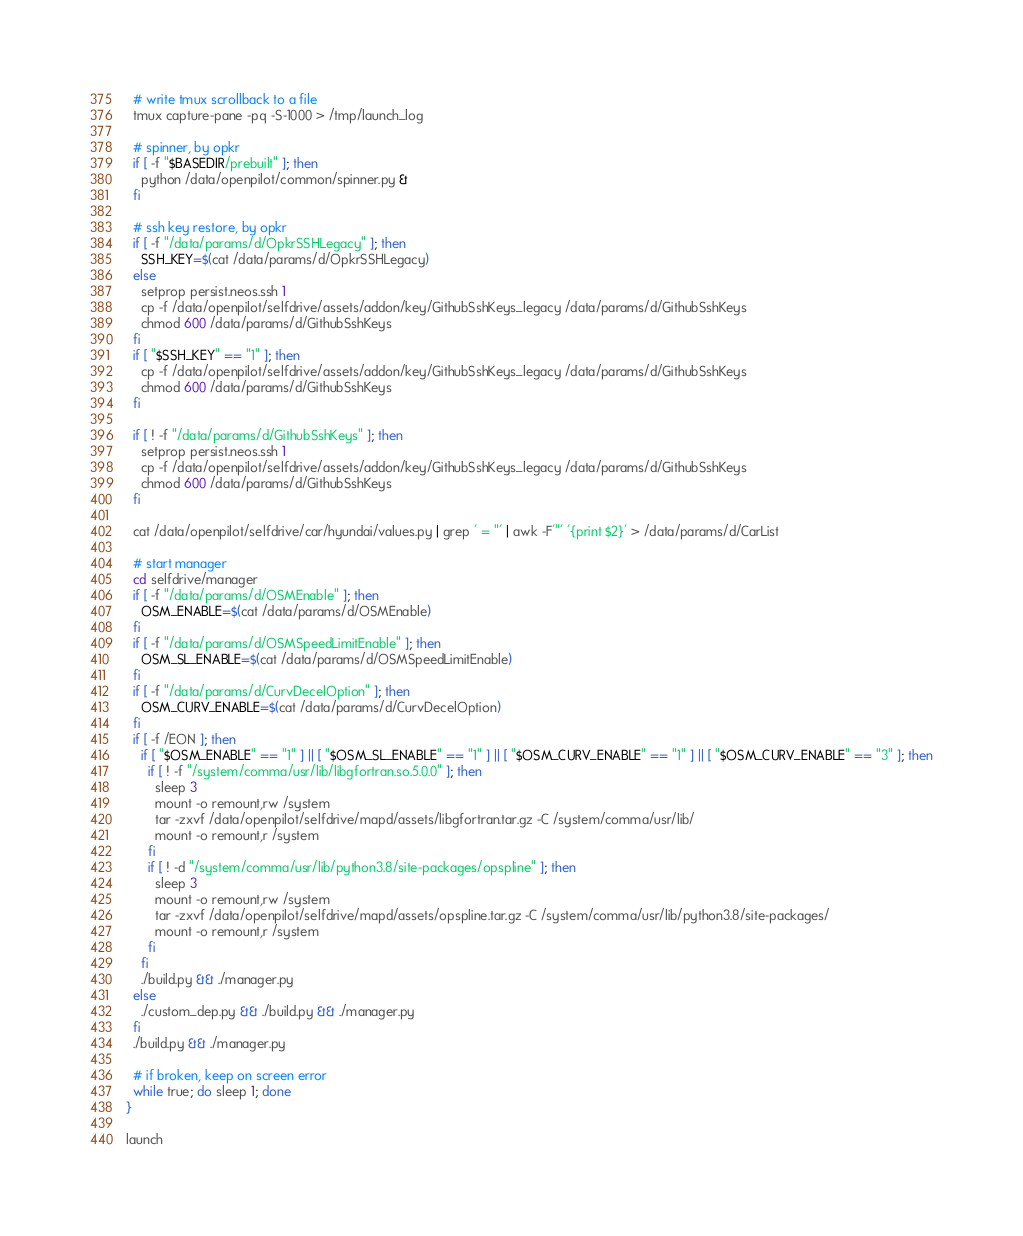<code> <loc_0><loc_0><loc_500><loc_500><_Bash_>  # write tmux scrollback to a file
  tmux capture-pane -pq -S-1000 > /tmp/launch_log

  # spinner, by opkr
  if [ -f "$BASEDIR/prebuilt" ]; then
    python /data/openpilot/common/spinner.py &
  fi

  # ssh key restore, by opkr
  if [ -f "/data/params/d/OpkrSSHLegacy" ]; then
    SSH_KEY=$(cat /data/params/d/OpkrSSHLegacy)
  else
    setprop persist.neos.ssh 1
    cp -f /data/openpilot/selfdrive/assets/addon/key/GithubSshKeys_legacy /data/params/d/GithubSshKeys
    chmod 600 /data/params/d/GithubSshKeys
  fi
  if [ "$SSH_KEY" == "1" ]; then
    cp -f /data/openpilot/selfdrive/assets/addon/key/GithubSshKeys_legacy /data/params/d/GithubSshKeys
    chmod 600 /data/params/d/GithubSshKeys
  fi

  if [ ! -f "/data/params/d/GithubSshKeys" ]; then
    setprop persist.neos.ssh 1
    cp -f /data/openpilot/selfdrive/assets/addon/key/GithubSshKeys_legacy /data/params/d/GithubSshKeys
    chmod 600 /data/params/d/GithubSshKeys
  fi

  cat /data/openpilot/selfdrive/car/hyundai/values.py | grep ' = "' | awk -F'"' '{print $2}' > /data/params/d/CarList

  # start manager  
  cd selfdrive/manager
  if [ -f "/data/params/d/OSMEnable" ]; then
    OSM_ENABLE=$(cat /data/params/d/OSMEnable)
  fi
  if [ -f "/data/params/d/OSMSpeedLimitEnable" ]; then
    OSM_SL_ENABLE=$(cat /data/params/d/OSMSpeedLimitEnable)
  fi
  if [ -f "/data/params/d/CurvDecelOption" ]; then
    OSM_CURV_ENABLE=$(cat /data/params/d/CurvDecelOption)
  fi
  if [ -f /EON ]; then
    if [ "$OSM_ENABLE" == "1" ] || [ "$OSM_SL_ENABLE" == "1" ] || [ "$OSM_CURV_ENABLE" == "1" ] || [ "$OSM_CURV_ENABLE" == "3" ]; then
      if [ ! -f "/system/comma/usr/lib/libgfortran.so.5.0.0" ]; then
        sleep 3
        mount -o remount,rw /system
        tar -zxvf /data/openpilot/selfdrive/mapd/assets/libgfortran.tar.gz -C /system/comma/usr/lib/
        mount -o remount,r /system
      fi
      if [ ! -d "/system/comma/usr/lib/python3.8/site-packages/opspline" ]; then
        sleep 3
        mount -o remount,rw /system
        tar -zxvf /data/openpilot/selfdrive/mapd/assets/opspline.tar.gz -C /system/comma/usr/lib/python3.8/site-packages/
        mount -o remount,r /system
      fi
    fi
    ./build.py && ./manager.py
  else
    ./custom_dep.py && ./build.py && ./manager.py
  fi
  ./build.py && ./manager.py

  # if broken, keep on screen error
  while true; do sleep 1; done
}

launch
</code> 